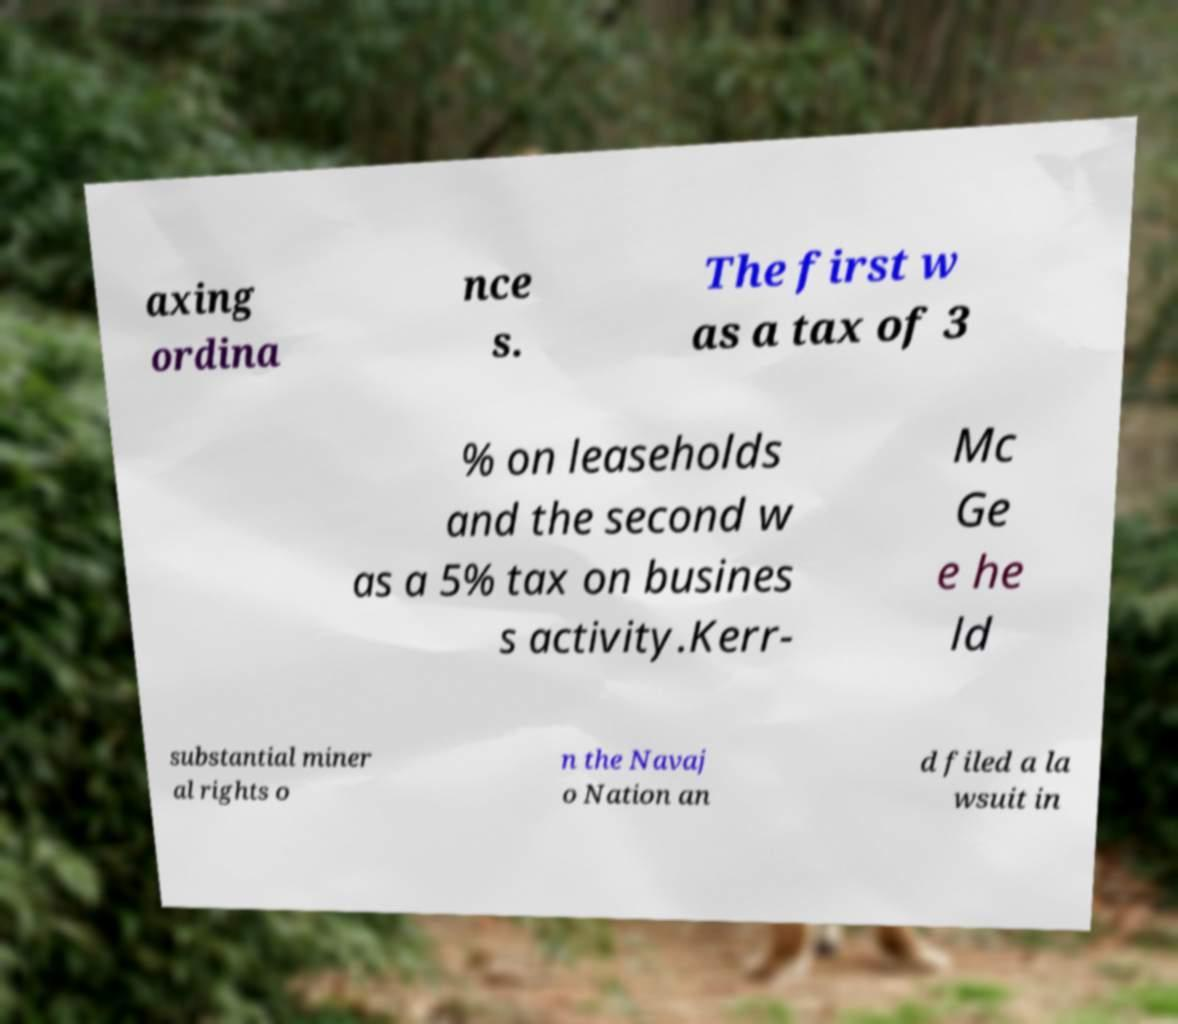There's text embedded in this image that I need extracted. Can you transcribe it verbatim? axing ordina nce s. The first w as a tax of 3 % on leaseholds and the second w as a 5% tax on busines s activity.Kerr- Mc Ge e he ld substantial miner al rights o n the Navaj o Nation an d filed a la wsuit in 